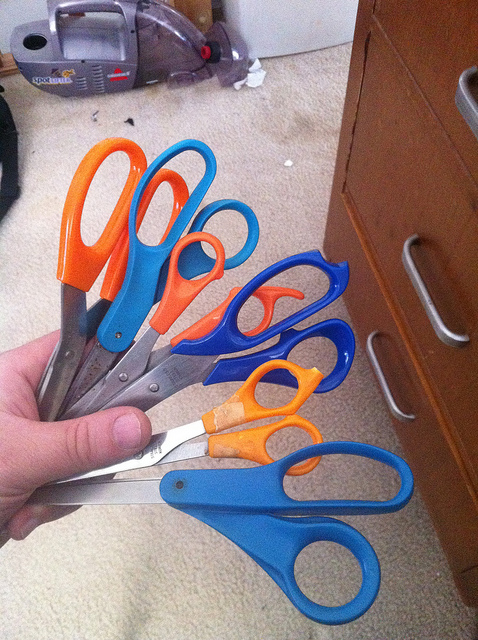Are these scissors intended for right or left-handed individuals, or are they universal? The scissors in the image are designed with symmetrical handle loops, which usually indicates they are suitable for both right-handed and left-handed users, providing a universal design. 